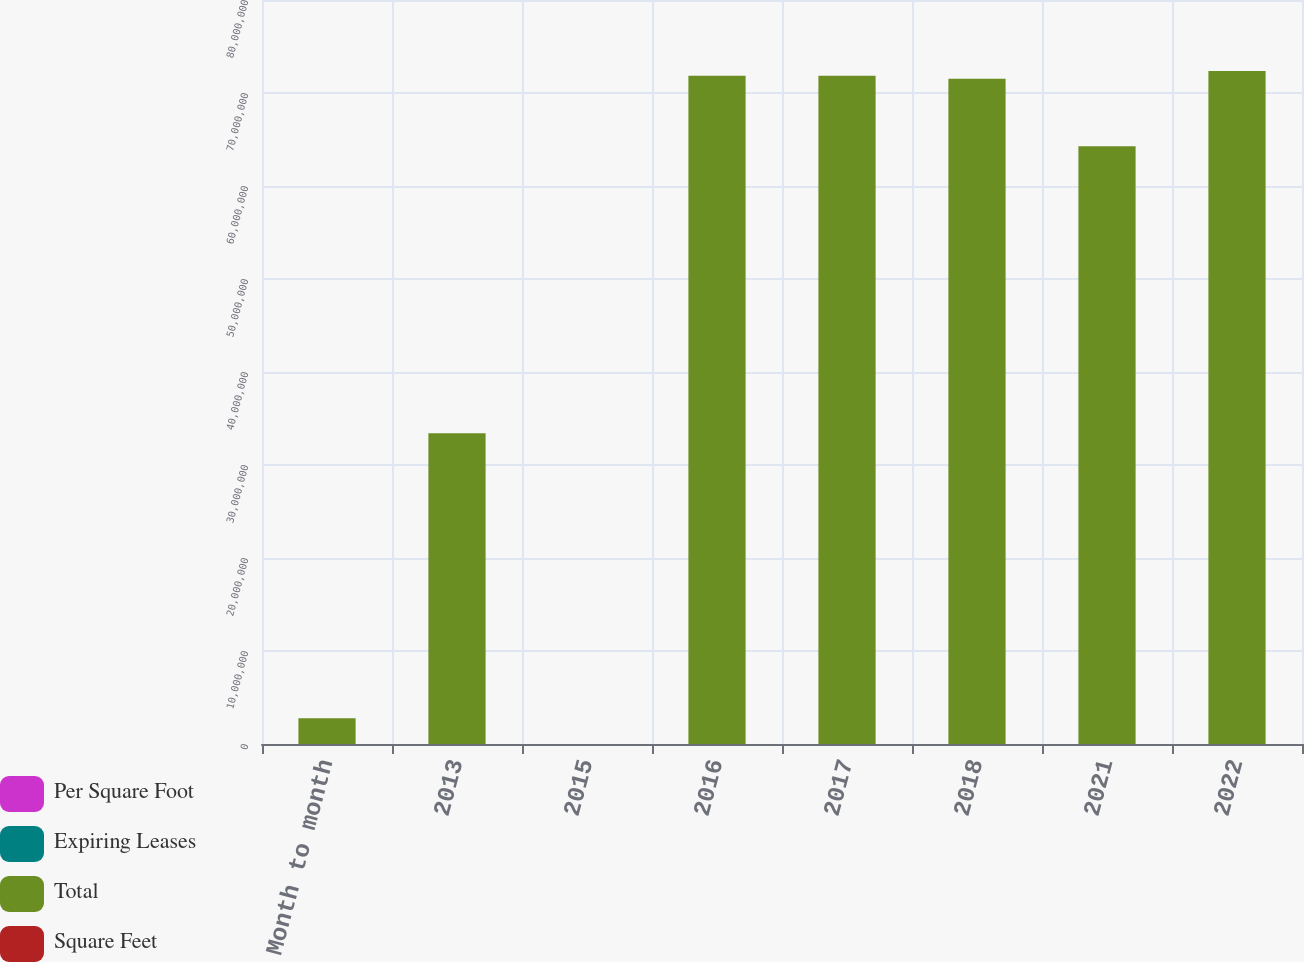Convert chart. <chart><loc_0><loc_0><loc_500><loc_500><stacked_bar_chart><ecel><fcel>Month to month<fcel>2013<fcel>2015<fcel>2016<fcel>2017<fcel>2018<fcel>2021<fcel>2022<nl><fcel>Per Square Foot<fcel>35<fcel>88<fcel>171<fcel>135<fcel>98<fcel>73<fcel>54<fcel>56<nl><fcel>Expiring Leases<fcel>0.3<fcel>4<fcel>12.9<fcel>7.5<fcel>7.6<fcel>6.6<fcel>6.5<fcel>7.2<nl><fcel>Total<fcel>2.759e+06<fcel>3.3411e+07<fcel>59.18<fcel>7.1848e+07<fcel>7.185e+07<fcel>7.1529e+07<fcel>6.4268e+07<fcel>7.2365e+07<nl><fcel>Square Feet<fcel>50.16<fcel>51.72<fcel>54.67<fcel>59.18<fcel>57.99<fcel>67.04<fcel>60.63<fcel>61.48<nl></chart> 